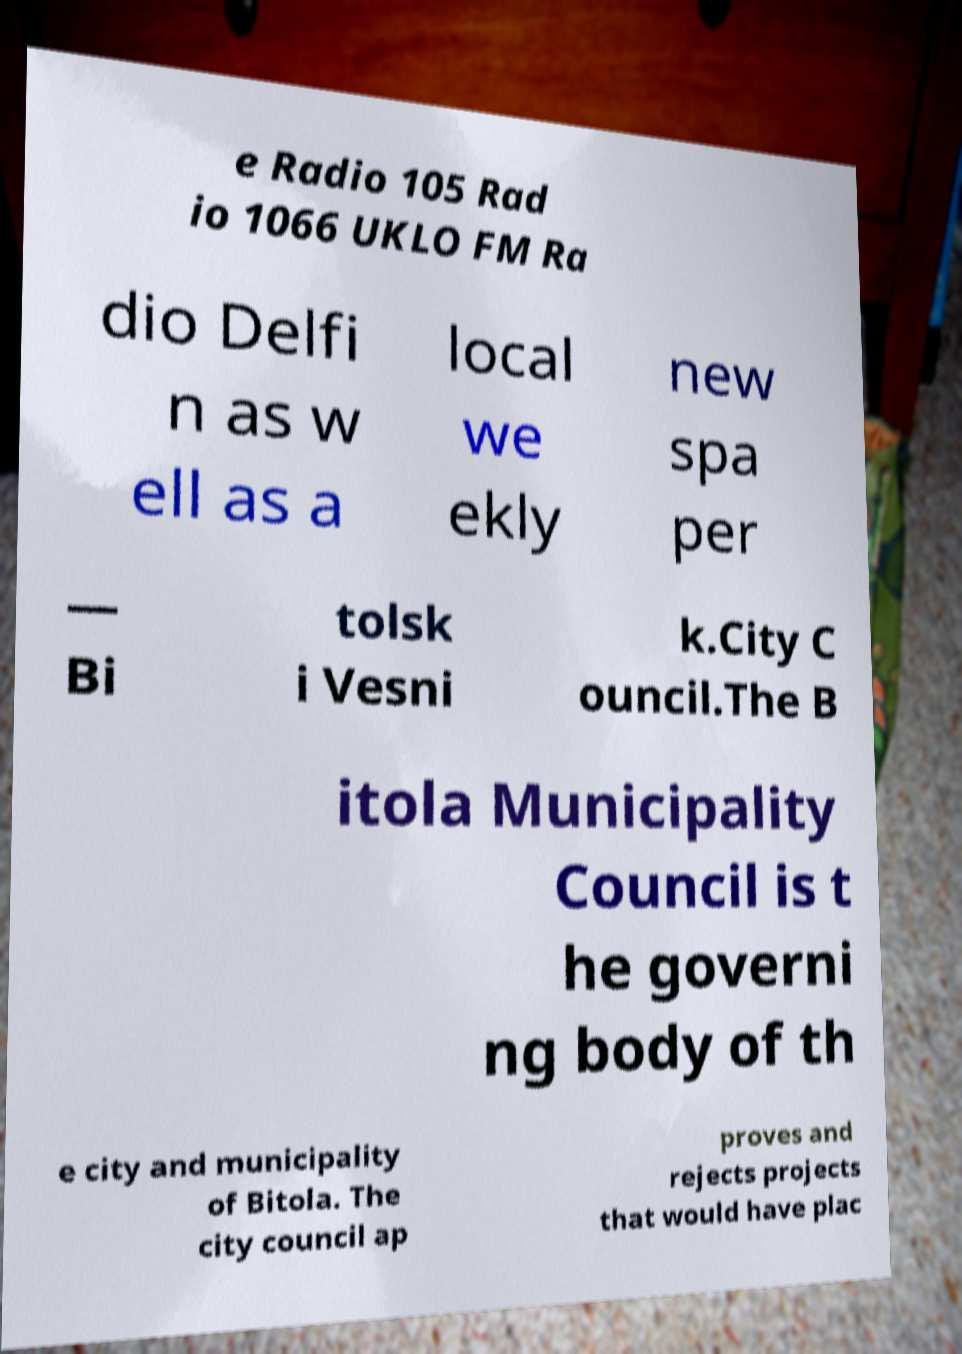Can you accurately transcribe the text from the provided image for me? e Radio 105 Rad io 1066 UKLO FM Ra dio Delfi n as w ell as a local we ekly new spa per — Bi tolsk i Vesni k.City C ouncil.The B itola Municipality Council is t he governi ng body of th e city and municipality of Bitola. The city council ap proves and rejects projects that would have plac 